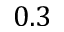Convert formula to latex. <formula><loc_0><loc_0><loc_500><loc_500>0 . 3</formula> 